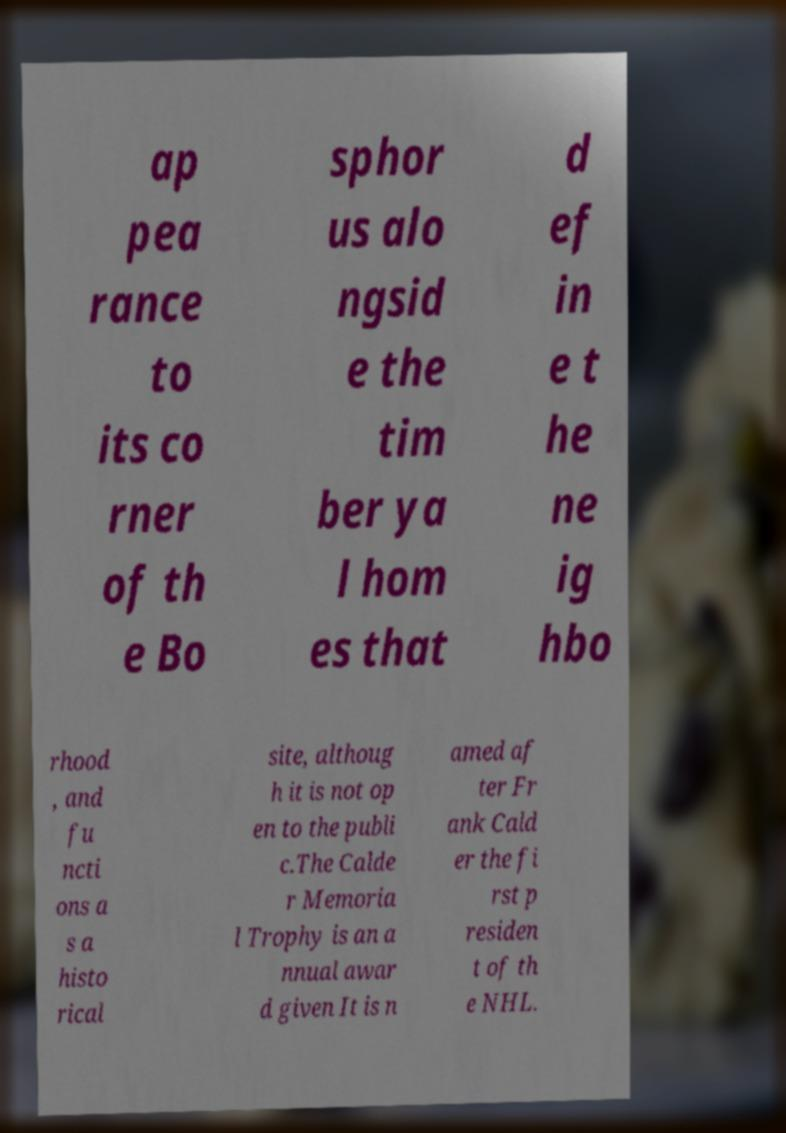Please read and relay the text visible in this image. What does it say? ap pea rance to its co rner of th e Bo sphor us alo ngsid e the tim ber ya l hom es that d ef in e t he ne ig hbo rhood , and fu ncti ons a s a histo rical site, althoug h it is not op en to the publi c.The Calde r Memoria l Trophy is an a nnual awar d given It is n amed af ter Fr ank Cald er the fi rst p residen t of th e NHL. 